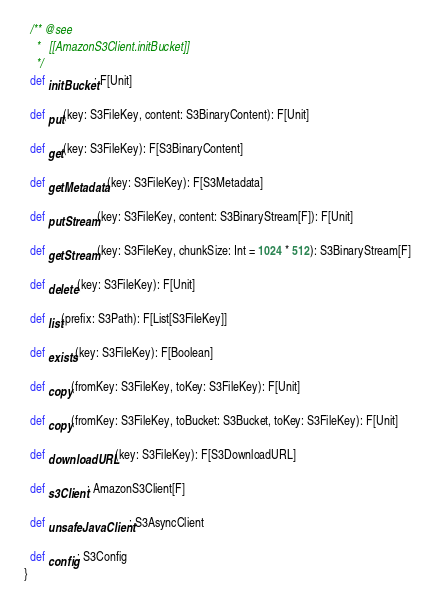<code> <loc_0><loc_0><loc_500><loc_500><_Scala_>
  /** @see
    *   [[AmazonS3Client.initBucket]]
    */
  def initBucket: F[Unit]

  def put(key: S3FileKey, content: S3BinaryContent): F[Unit]

  def get(key: S3FileKey): F[S3BinaryContent]

  def getMetadata(key: S3FileKey): F[S3Metadata]

  def putStream(key: S3FileKey, content: S3BinaryStream[F]): F[Unit]

  def getStream(key: S3FileKey, chunkSize: Int = 1024 * 512): S3BinaryStream[F]

  def delete(key: S3FileKey): F[Unit]

  def list(prefix: S3Path): F[List[S3FileKey]]

  def exists(key: S3FileKey): F[Boolean]

  def copy(fromKey: S3FileKey, toKey: S3FileKey): F[Unit]

  def copy(fromKey: S3FileKey, toBucket: S3Bucket, toKey: S3FileKey): F[Unit]

  def downloadURL(key: S3FileKey): F[S3DownloadURL]

  def s3Client: AmazonS3Client[F]

  def unsafeJavaClient: S3AsyncClient

  def config: S3Config
}
</code> 